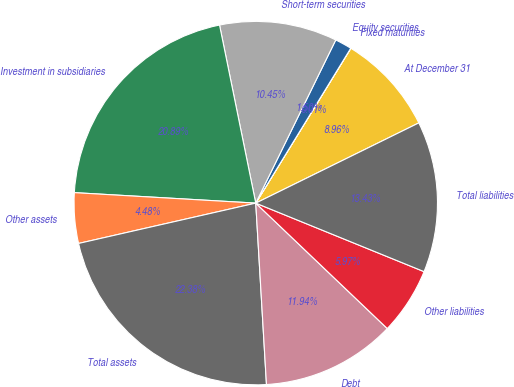Convert chart to OTSL. <chart><loc_0><loc_0><loc_500><loc_500><pie_chart><fcel>At December 31<fcel>Fixed maturities<fcel>Equity securities<fcel>Short-term securities<fcel>Investment in subsidiaries<fcel>Other assets<fcel>Total assets<fcel>Debt<fcel>Other liabilities<fcel>Total liabilities<nl><fcel>8.96%<fcel>0.01%<fcel>1.5%<fcel>10.45%<fcel>20.89%<fcel>4.48%<fcel>22.38%<fcel>11.94%<fcel>5.97%<fcel>13.43%<nl></chart> 